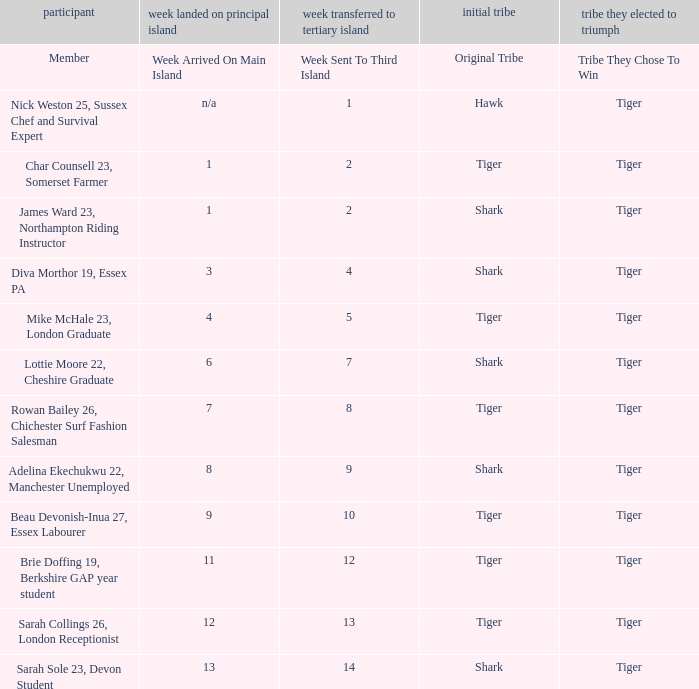Who was sent to the third island in week 1? Nick Weston 25, Sussex Chef and Survival Expert. 